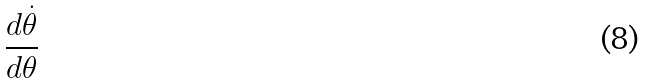<formula> <loc_0><loc_0><loc_500><loc_500>\frac { d \dot { \theta } } { d \theta }</formula> 